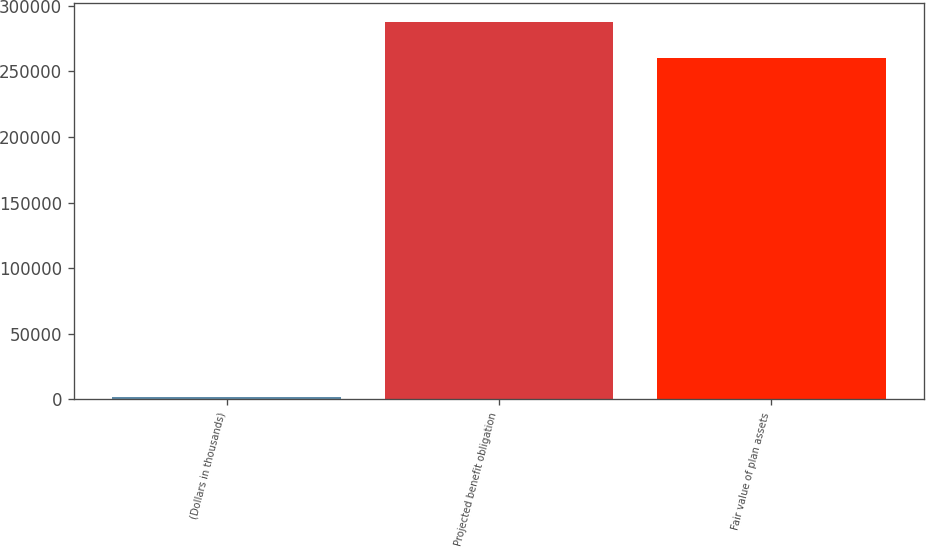<chart> <loc_0><loc_0><loc_500><loc_500><bar_chart><fcel>(Dollars in thousands)<fcel>Projected benefit obligation<fcel>Fair value of plan assets<nl><fcel>2018<fcel>287906<fcel>260531<nl></chart> 